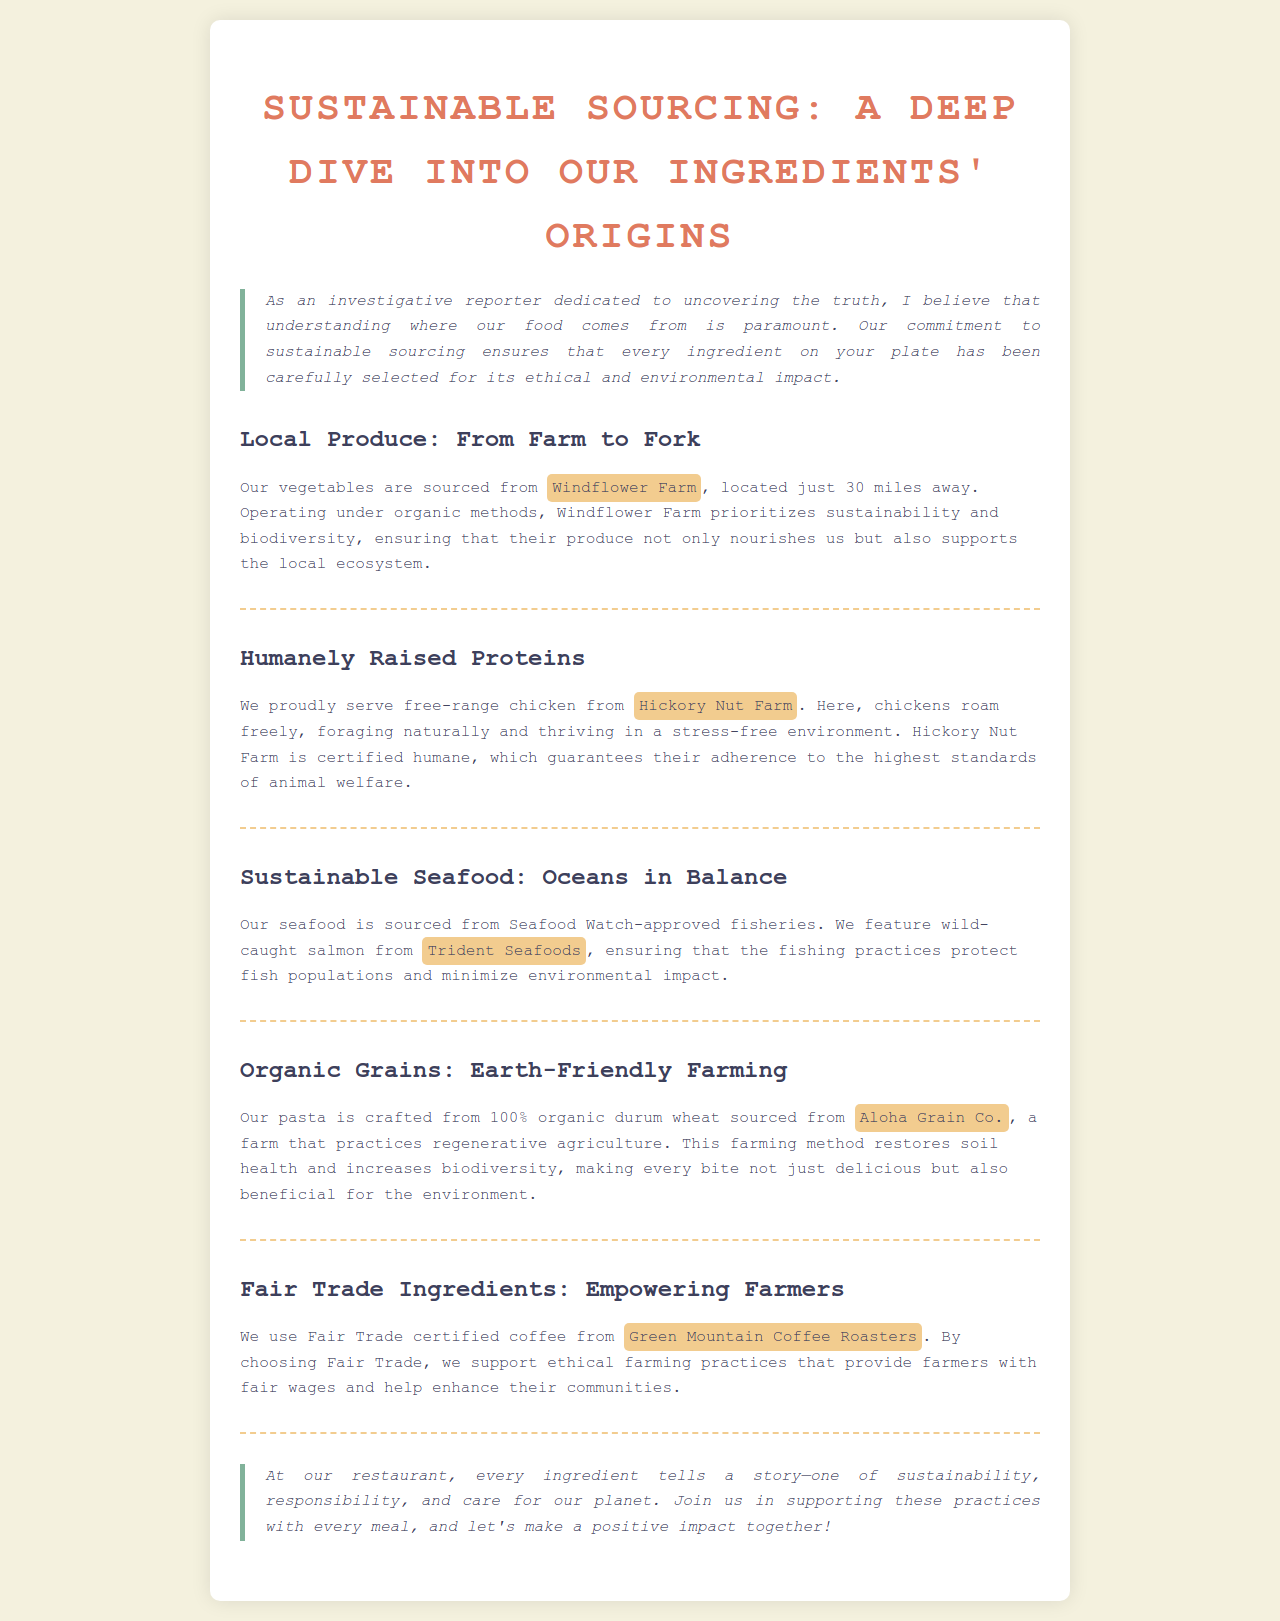What farm supplies your vegetables? The document states that the vegetables are sourced from Windflower Farm.
Answer: Windflower Farm How far is Windflower Farm from the restaurant? The distance to Windflower Farm is mentioned in the document as 30 miles.
Answer: 30 miles What is the source of your chicken? It is specified in the document that the chicken comes from Hickory Nut Farm.
Answer: Hickory Nut Farm What type of seafood is served in the restaurant? The document mentions that wild-caught salmon is served at the restaurant.
Answer: Wild-caught salmon What coffee brand does the restaurant use? The document indicates that the restaurant uses Green Mountain Coffee Roasters for its coffee.
Answer: Green Mountain Coffee Roasters What farming method does Aloha Grain Co. practice? The document states that Aloha Grain Co. practices regenerative agriculture.
Answer: Regenerative agriculture Why is it important to source sustainable seafood? The document explains that sustainable seafood sourcing protects fish populations and minimizes environmental impact.
Answer: Protects fish populations What certification is required for the chicken? According to the document, Hickory Nut Farm is certified humane.
Answer: Certified humane What is the main benefit of Fair Trade coffee? The document highlights that Fair Trade support ethical farming practices and fair wages for farmers.
Answer: Fair wages for farmers 